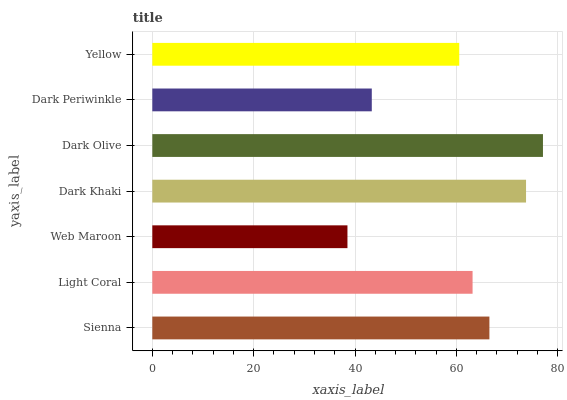Is Web Maroon the minimum?
Answer yes or no. Yes. Is Dark Olive the maximum?
Answer yes or no. Yes. Is Light Coral the minimum?
Answer yes or no. No. Is Light Coral the maximum?
Answer yes or no. No. Is Sienna greater than Light Coral?
Answer yes or no. Yes. Is Light Coral less than Sienna?
Answer yes or no. Yes. Is Light Coral greater than Sienna?
Answer yes or no. No. Is Sienna less than Light Coral?
Answer yes or no. No. Is Light Coral the high median?
Answer yes or no. Yes. Is Light Coral the low median?
Answer yes or no. Yes. Is Dark Olive the high median?
Answer yes or no. No. Is Dark Olive the low median?
Answer yes or no. No. 